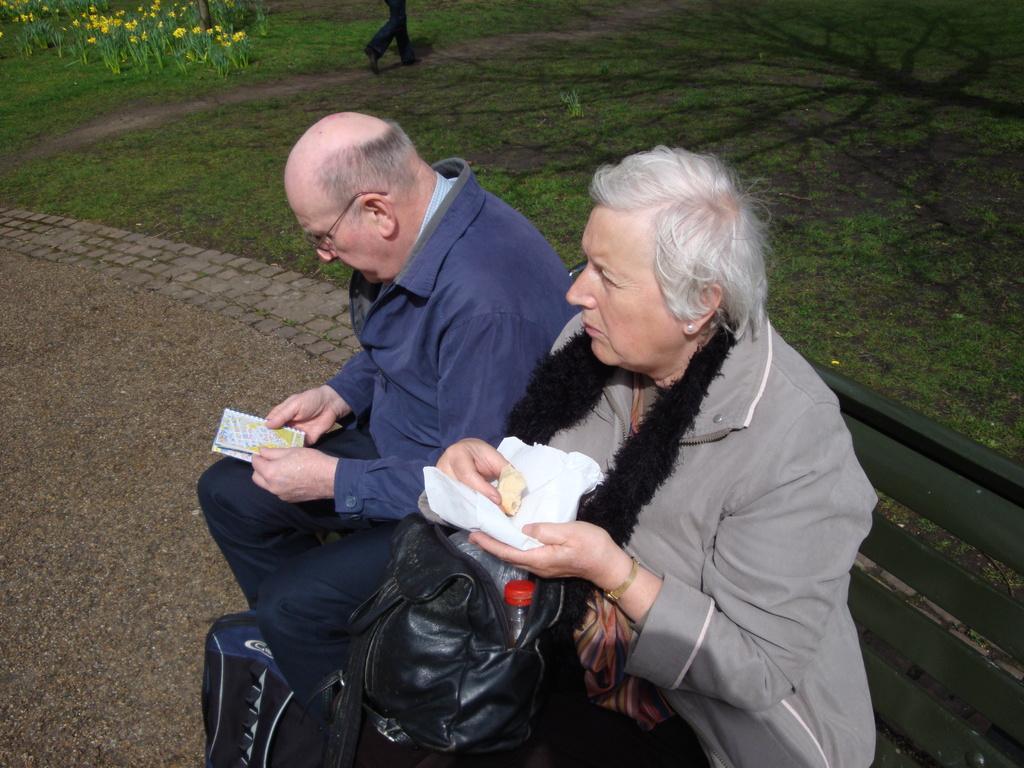Could you give a brief overview of what you see in this image? In this picture we can see person legs, grass, yellow flowers and green leaves. On the right side we can see a man and a woman sitting on the bench. This woman is holding a white paper and food in her hands. We can see a bottle in a black bag. At the bottom we can see a bag on the floor. This man wore spectacles and he is holding a small book. 